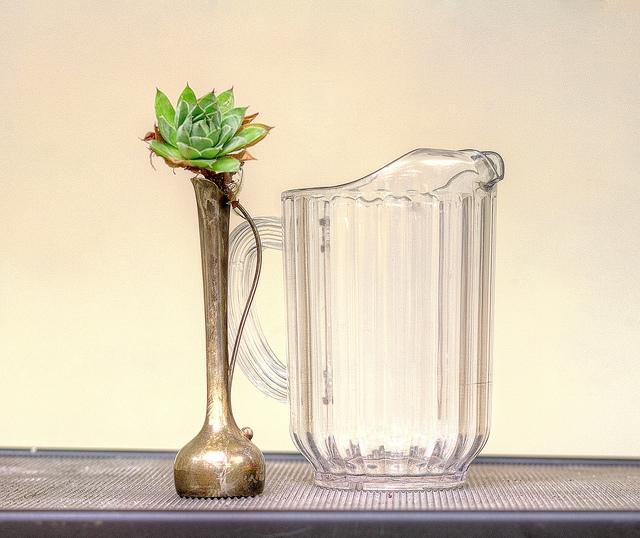What are they showing with this display? pitcher 